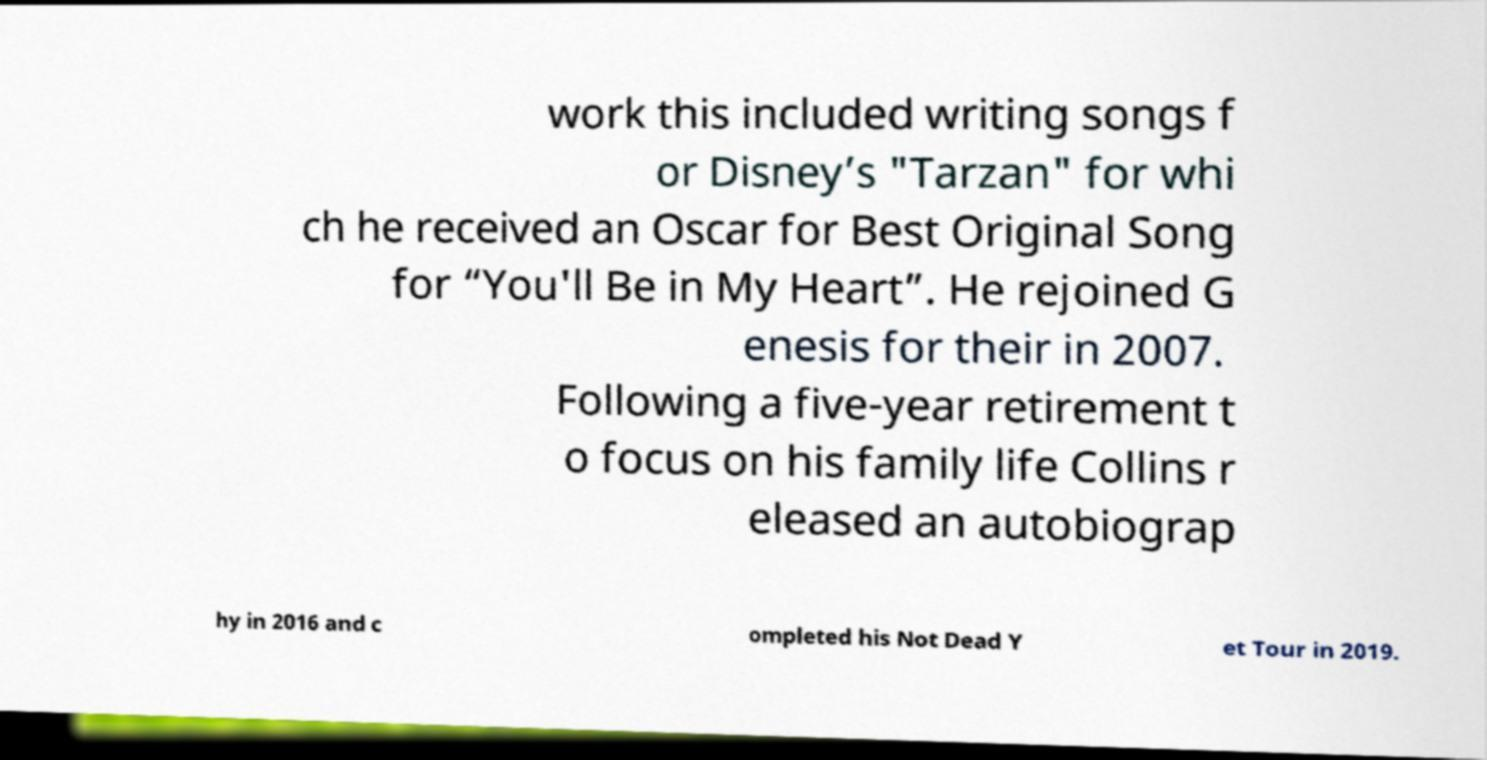What messages or text are displayed in this image? I need them in a readable, typed format. work this included writing songs f or Disney’s "Tarzan" for whi ch he received an Oscar for Best Original Song for “You'll Be in My Heart”. He rejoined G enesis for their in 2007. Following a five-year retirement t o focus on his family life Collins r eleased an autobiograp hy in 2016 and c ompleted his Not Dead Y et Tour in 2019. 